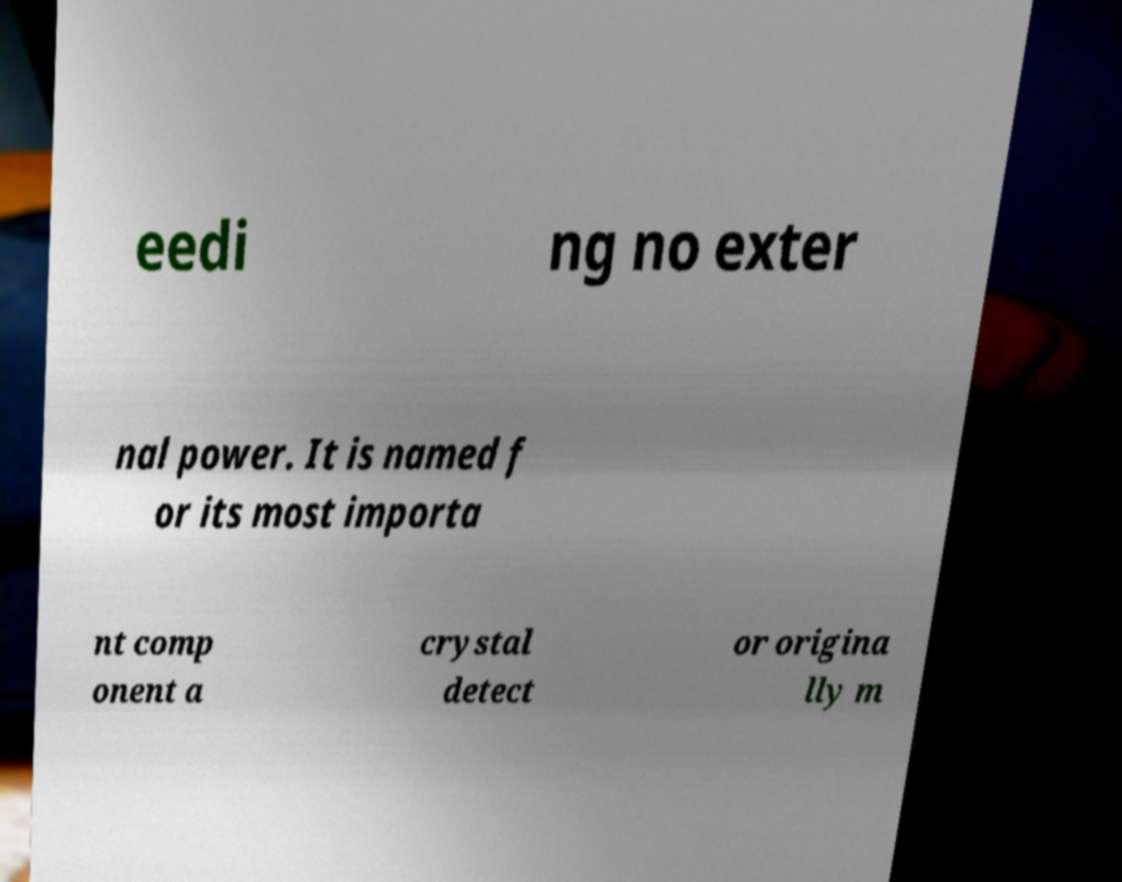Can you read and provide the text displayed in the image?This photo seems to have some interesting text. Can you extract and type it out for me? eedi ng no exter nal power. It is named f or its most importa nt comp onent a crystal detect or origina lly m 